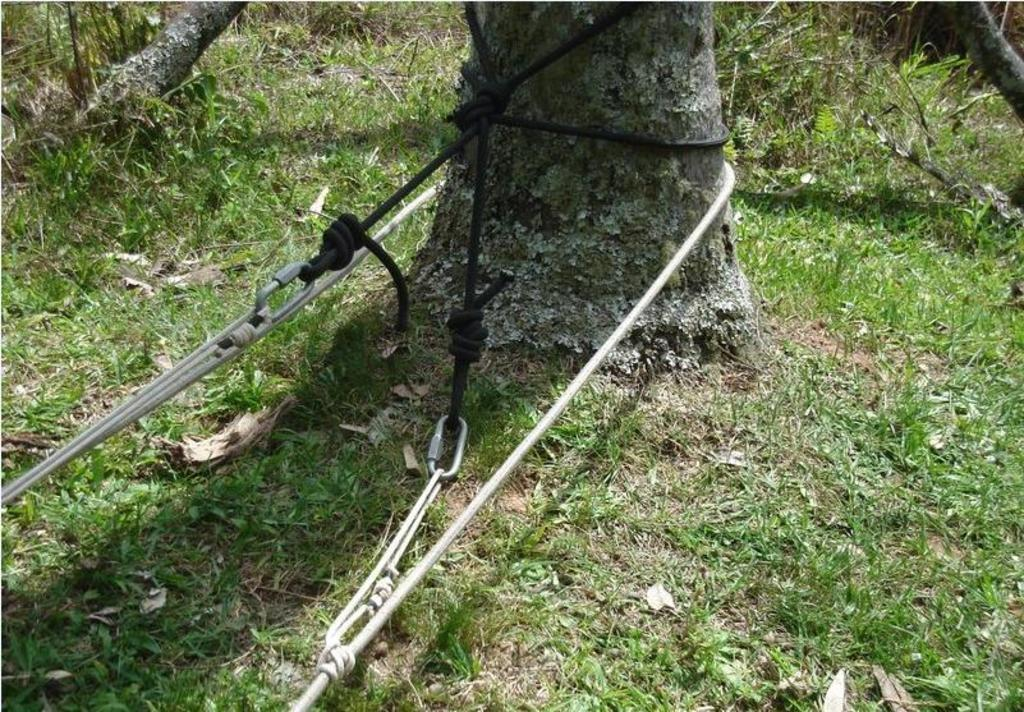What is connected to the tree in the image? There are ropes tied to a tree in the image. What objects can be found on the ground in the image? There are sticks and plants on the ground in the image. What type of vegetation is present on the ground in the image? There is grass on the ground in the image. What scent can be detected from the plants in the image? The image does not provide information about the scent of the plants, so it cannot be determined from the image. How far away is the seashore from the scene in the image? The image does not show any seashore, so it cannot be determined how far away it might be. 